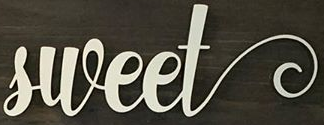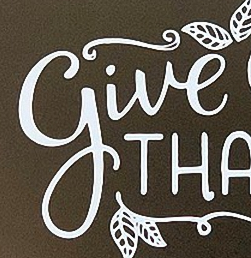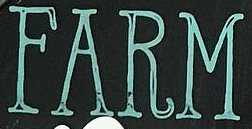Read the text from these images in sequence, separated by a semicolon. sweet; give; FARM 